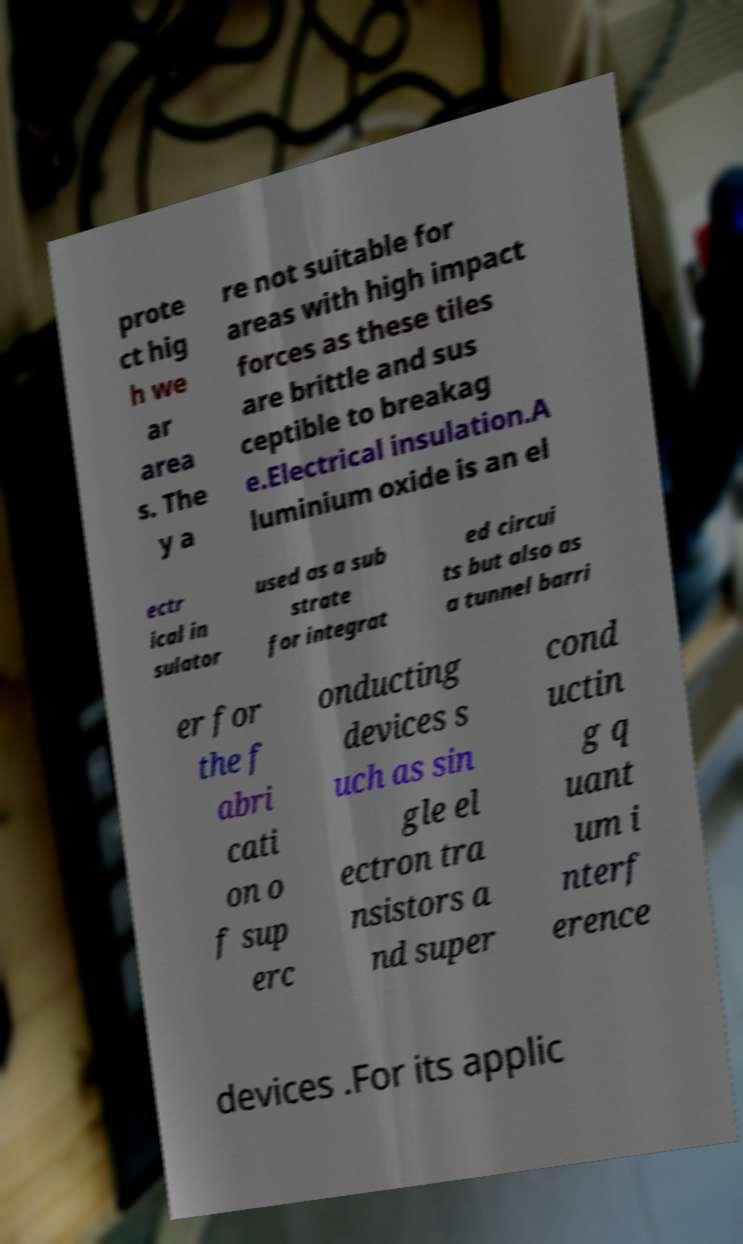What messages or text are displayed in this image? I need them in a readable, typed format. prote ct hig h we ar area s. The y a re not suitable for areas with high impact forces as these tiles are brittle and sus ceptible to breakag e.Electrical insulation.A luminium oxide is an el ectr ical in sulator used as a sub strate for integrat ed circui ts but also as a tunnel barri er for the f abri cati on o f sup erc onducting devices s uch as sin gle el ectron tra nsistors a nd super cond uctin g q uant um i nterf erence devices .For its applic 